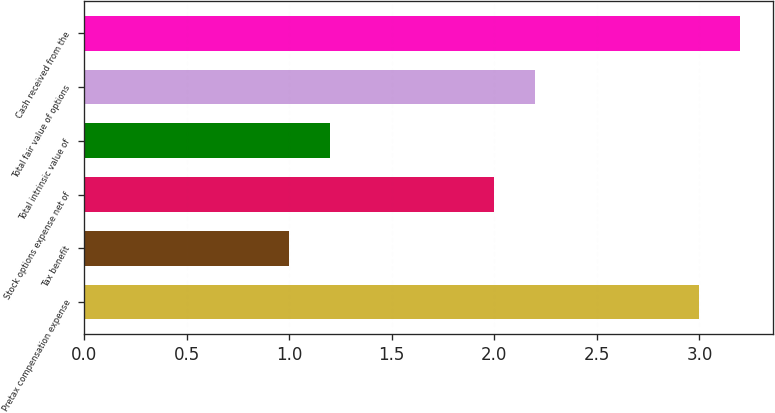Convert chart. <chart><loc_0><loc_0><loc_500><loc_500><bar_chart><fcel>Pretax compensation expense<fcel>Tax benefit<fcel>Stock options expense net of<fcel>Total intrinsic value of<fcel>Total fair value of options<fcel>Cash received from the<nl><fcel>3<fcel>1<fcel>2<fcel>1.2<fcel>2.2<fcel>3.2<nl></chart> 